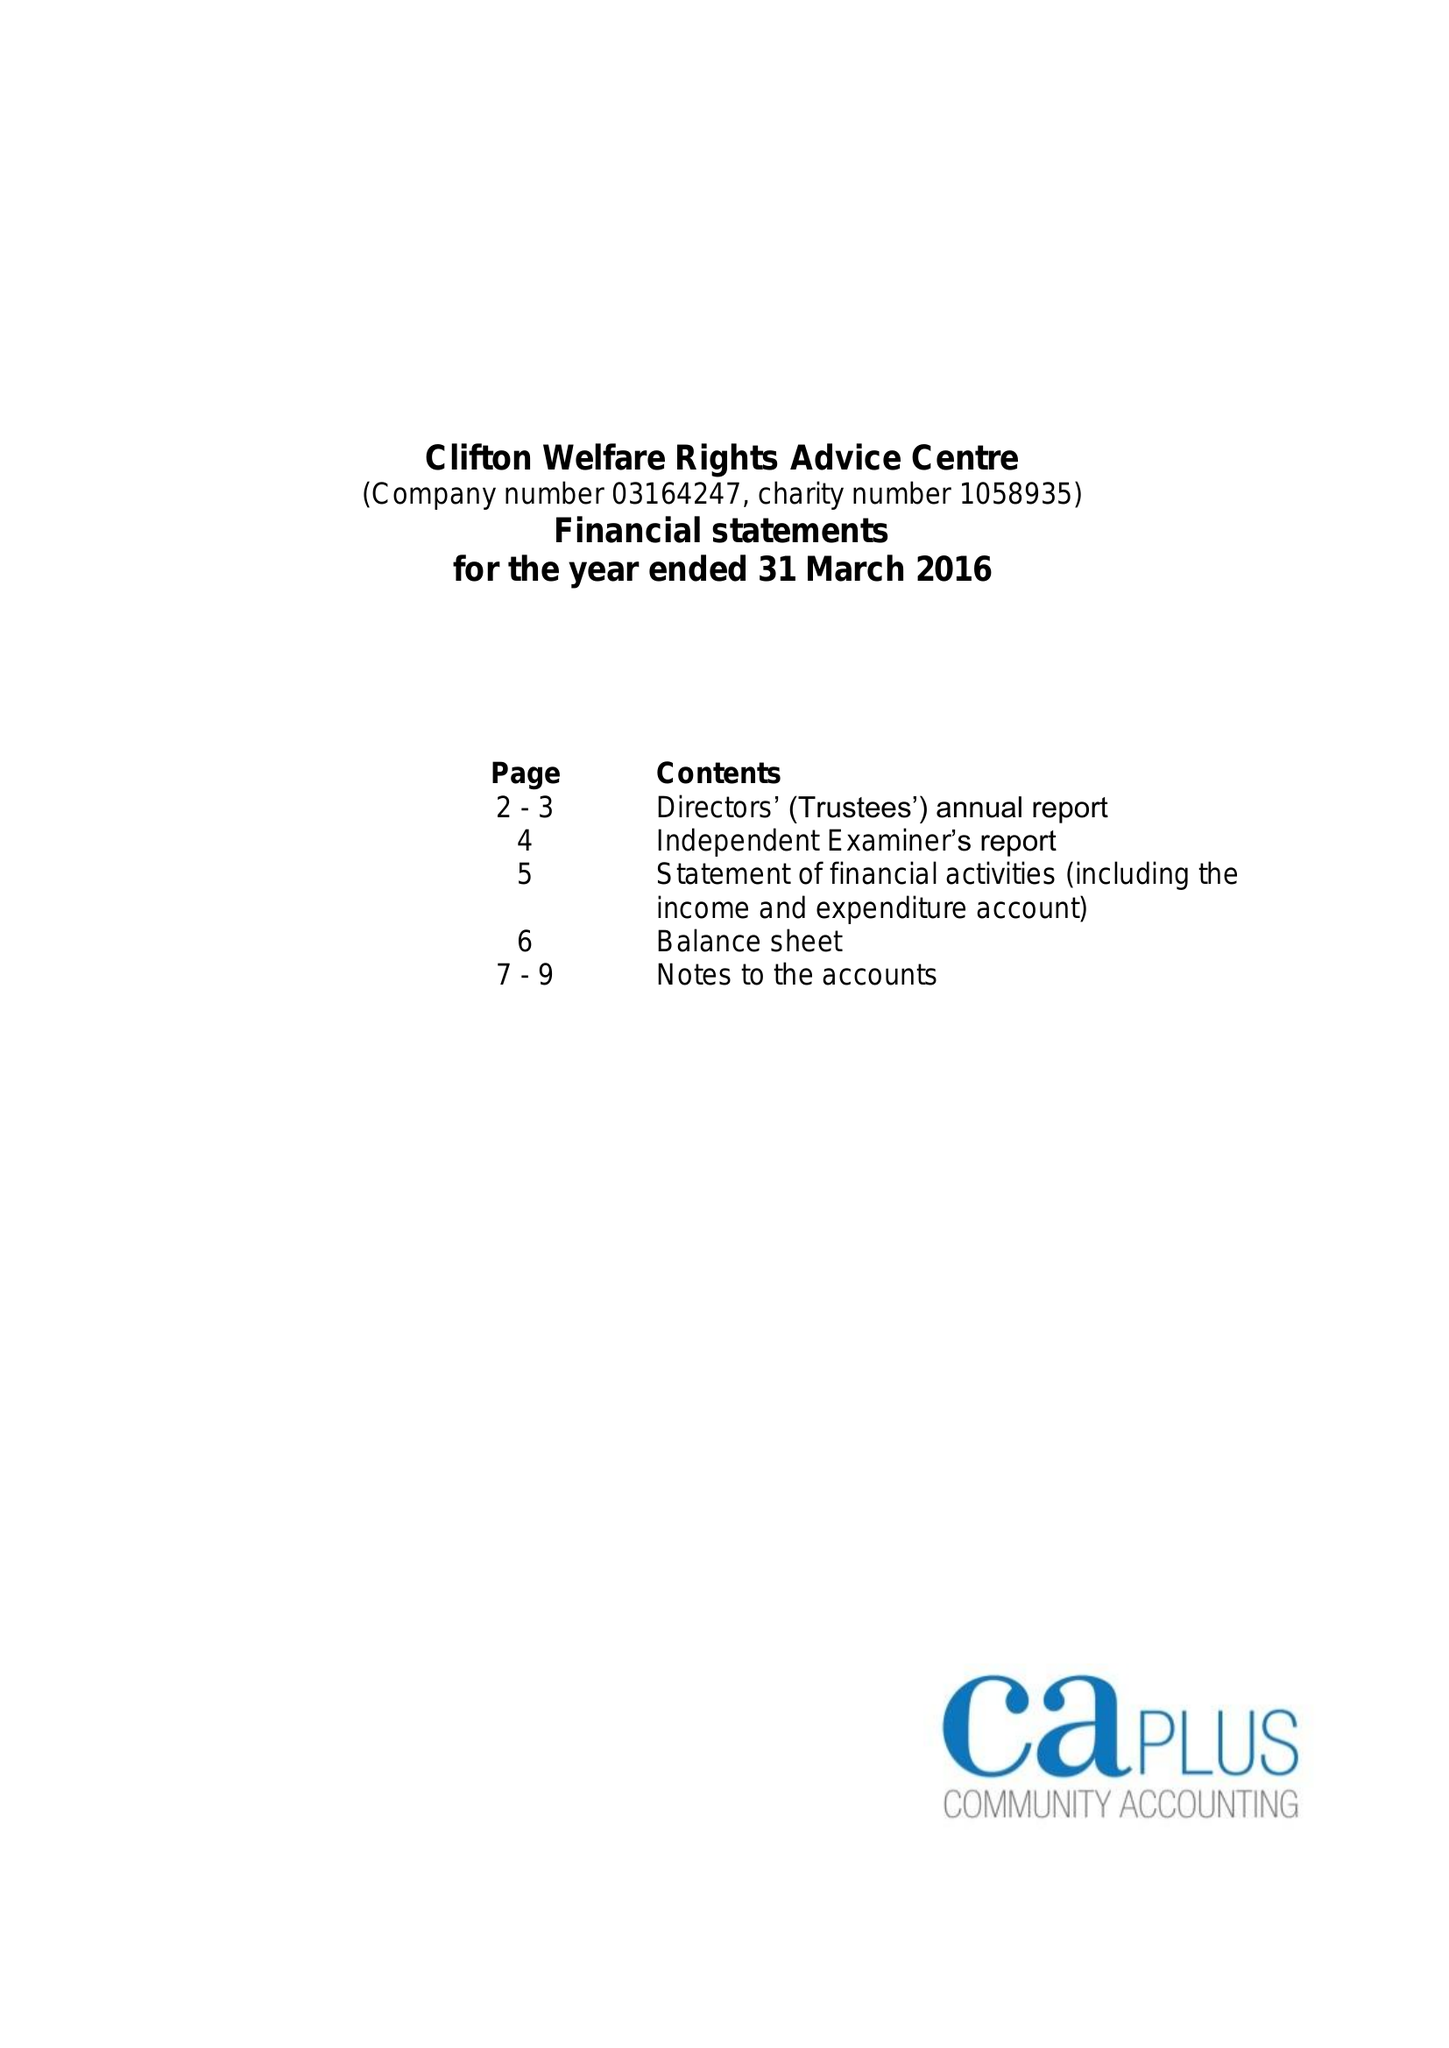What is the value for the report_date?
Answer the question using a single word or phrase. 2016-03-31 